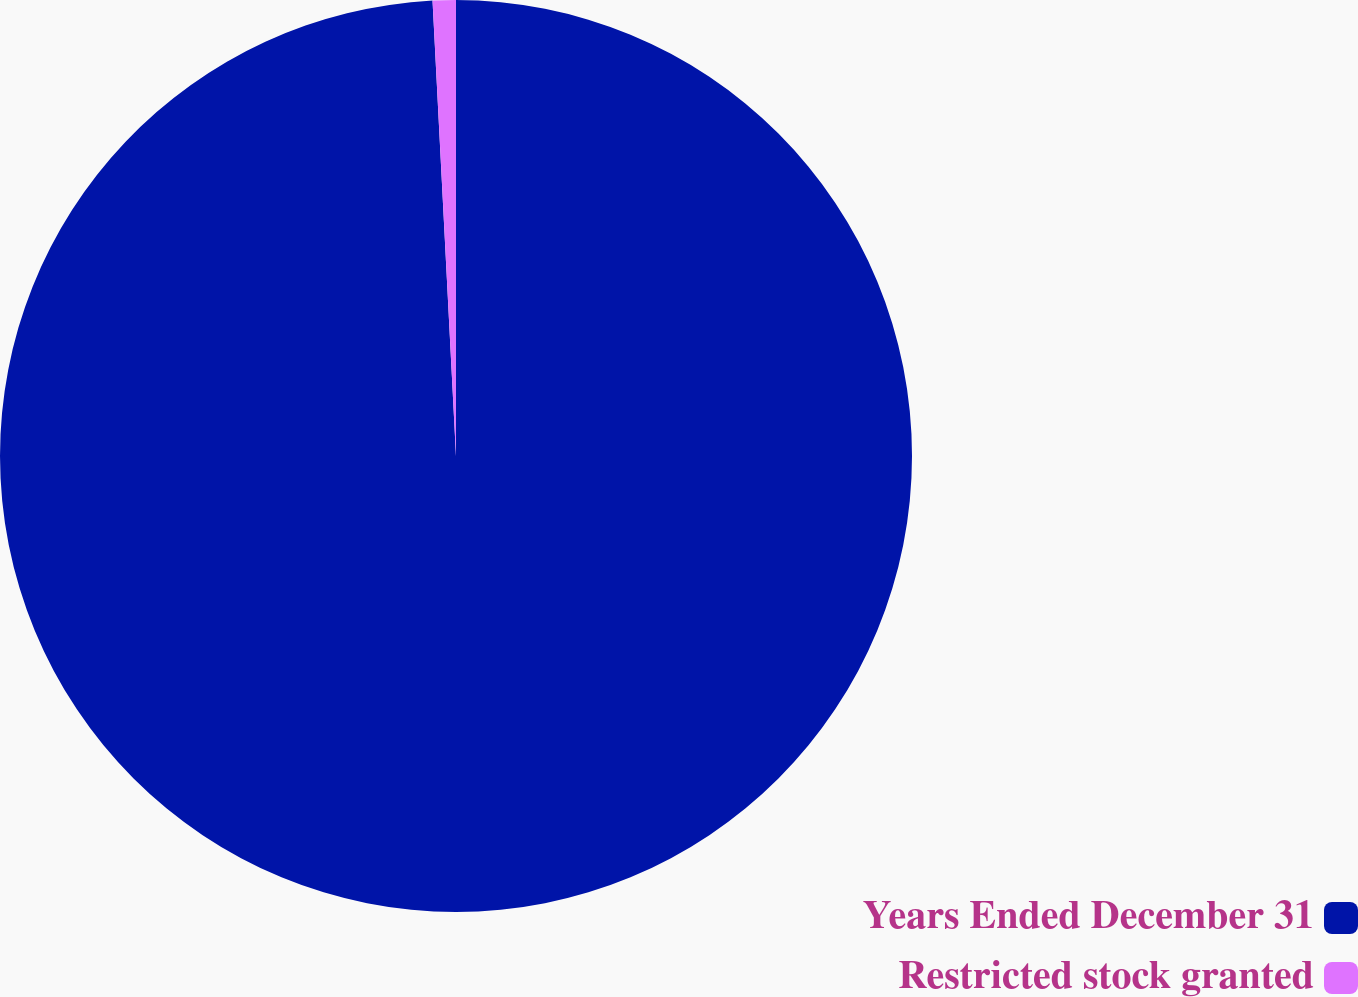Convert chart to OTSL. <chart><loc_0><loc_0><loc_500><loc_500><pie_chart><fcel>Years Ended December 31<fcel>Restricted stock granted<nl><fcel>99.18%<fcel>0.82%<nl></chart> 